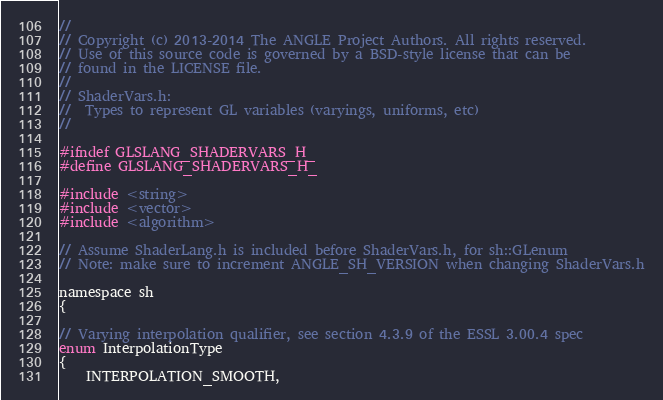Convert code to text. <code><loc_0><loc_0><loc_500><loc_500><_C_>//
// Copyright (c) 2013-2014 The ANGLE Project Authors. All rights reserved.
// Use of this source code is governed by a BSD-style license that can be
// found in the LICENSE file.
//
// ShaderVars.h:
//  Types to represent GL variables (varyings, uniforms, etc)
//

#ifndef GLSLANG_SHADERVARS_H_
#define GLSLANG_SHADERVARS_H_

#include <string>
#include <vector>
#include <algorithm>

// Assume ShaderLang.h is included before ShaderVars.h, for sh::GLenum
// Note: make sure to increment ANGLE_SH_VERSION when changing ShaderVars.h

namespace sh
{

// Varying interpolation qualifier, see section 4.3.9 of the ESSL 3.00.4 spec
enum InterpolationType
{
    INTERPOLATION_SMOOTH,</code> 